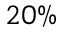<formula> <loc_0><loc_0><loc_500><loc_500>2 0 \%</formula> 